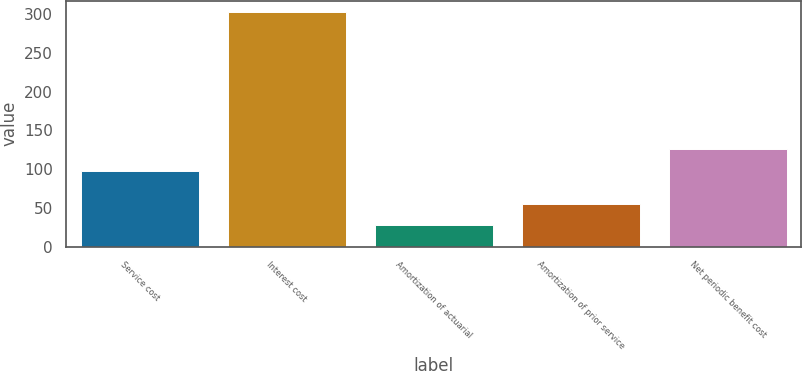<chart> <loc_0><loc_0><loc_500><loc_500><bar_chart><fcel>Service cost<fcel>Interest cost<fcel>Amortization of actuarial<fcel>Amortization of prior service<fcel>Net periodic benefit cost<nl><fcel>98<fcel>302<fcel>28<fcel>55.4<fcel>125.4<nl></chart> 